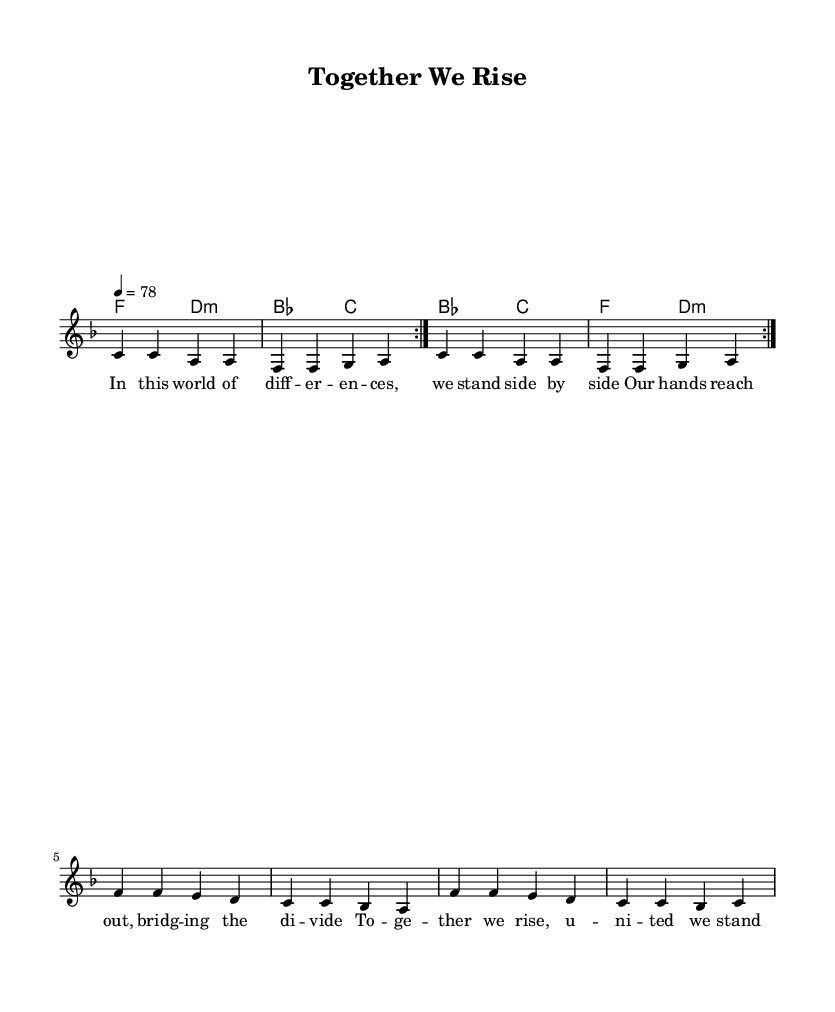What is the key signature of this music? The key signature is F major, which has one flat (B flat). You can identify the key signature by looking at the beginning of the staff where the flats or sharps are indicated.
Answer: F major What is the time signature of this piece? The time signature is 4/4, which indicates four beats per measure, and a quarter note gets one beat. This can be found at the beginning of the sheet music.
Answer: 4/4 What is the tempo marking for this music? The tempo marking is 78 beats per minute, indicated by the text "4 = 78" at the beginning. This tells musicians how fast to play the piece.
Answer: 78 How many measures are there in the chorus section? The chorus section consists of two measures, where each line of lyrics corresponds to one measure of music. By counting the sets of four beats in the lyric lines, we can see that two measures are presented.
Answer: 2 What is the mood conveyed by the lyrics? The mood conveyed is one of unity and hope, as shown through phrases like "Together we rise, united we stand," suggesting a positive and collaborative spirit. This can be inferred from the lyrics emphasizing solidarity and love.
Answer: Unity What type of chords are used in the harmonies section? The harmonies include major (F, B flat, C) and minor chords (D minor). You can identify the chord types by recognizing the structure of the notes in each chord symbol indicated in the score.
Answer: Major and minor What themes are expressed in this piece? The themes expressed are unity and love, reflected in the lyrics and the overall message conveyed by the title "Together We Rise." Analyzing the lyrics supports this interpretation with messages of standing together.
Answer: Unity and love 